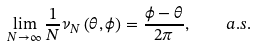<formula> <loc_0><loc_0><loc_500><loc_500>\lim _ { N \rightarrow \infty } \frac { 1 } { N } \nu _ { N } \left ( \theta , \phi \right ) = \frac { \phi - \theta } { 2 \pi } , \quad a . s .</formula> 